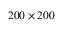Convert formula to latex. <formula><loc_0><loc_0><loc_500><loc_500>2 0 0 \times 2 0 0</formula> 